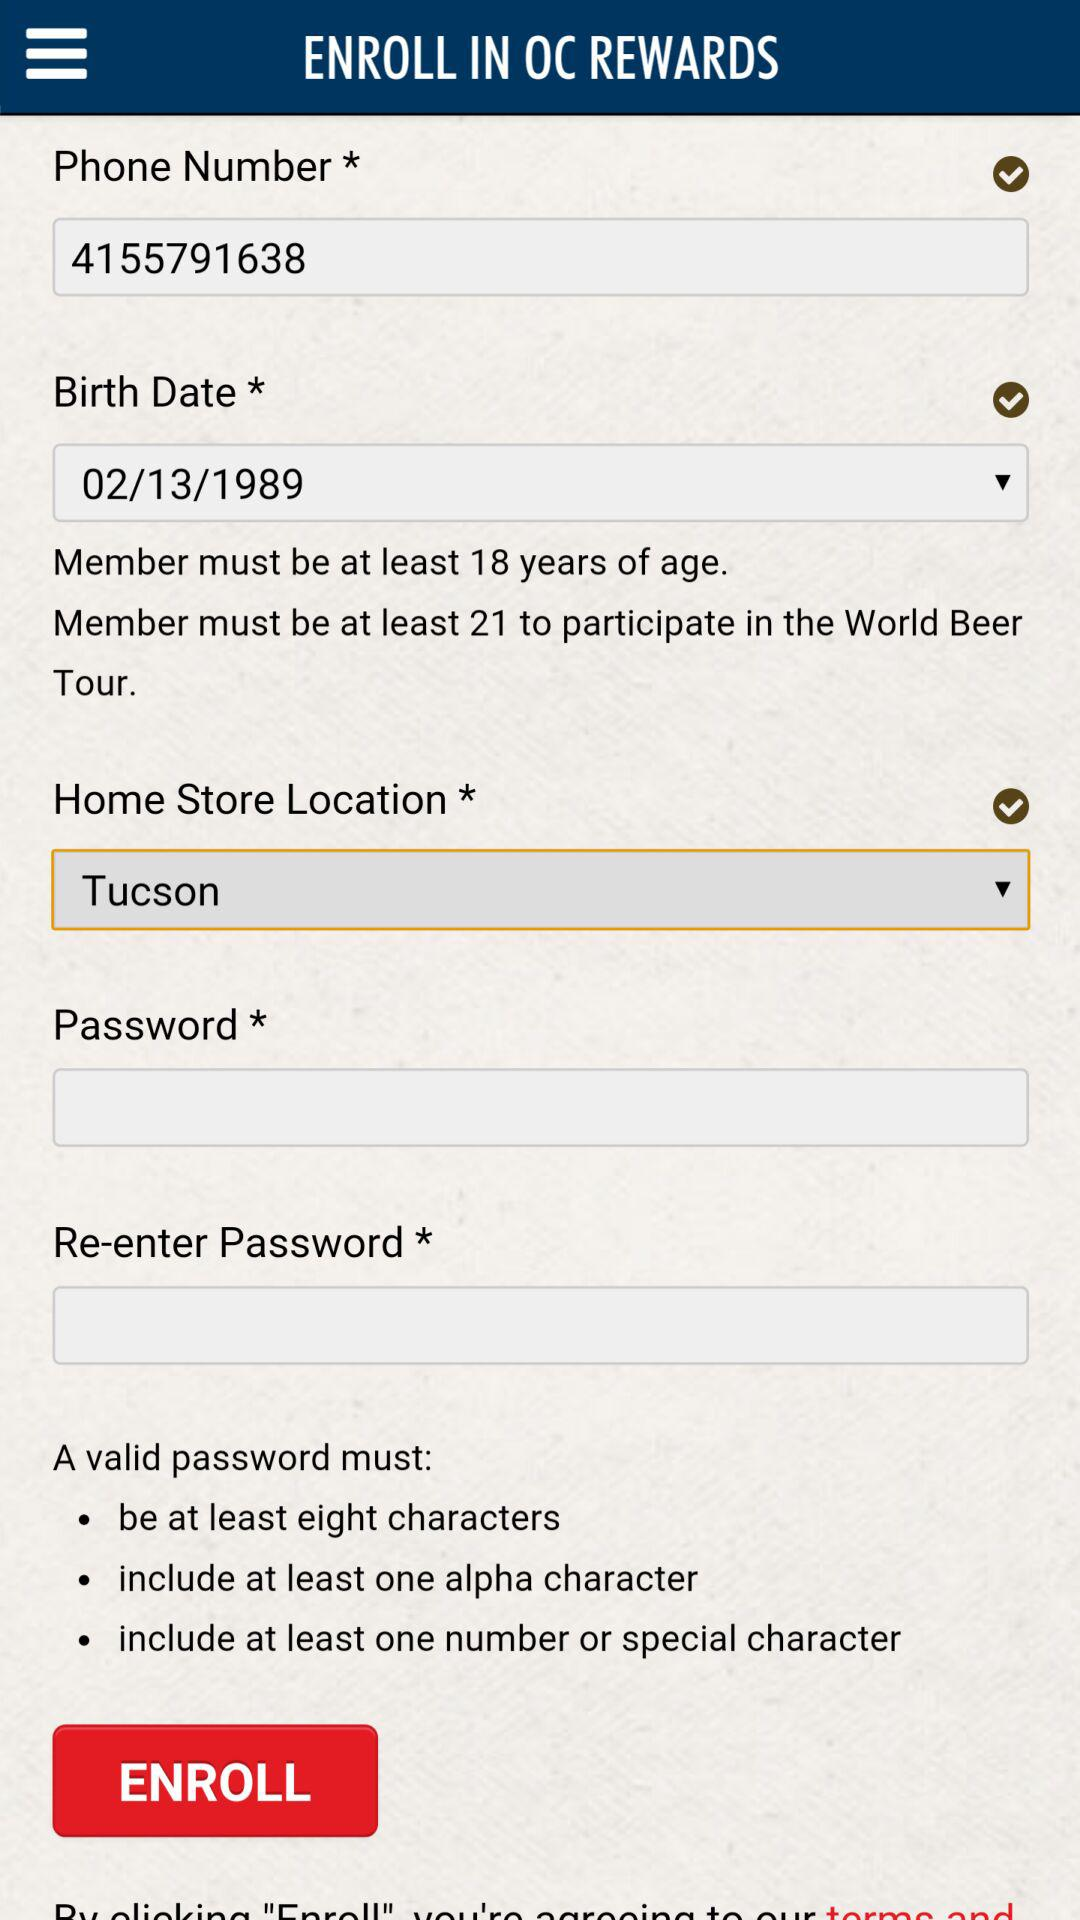Which home store location was selected? The selected home store location was Tucson. 